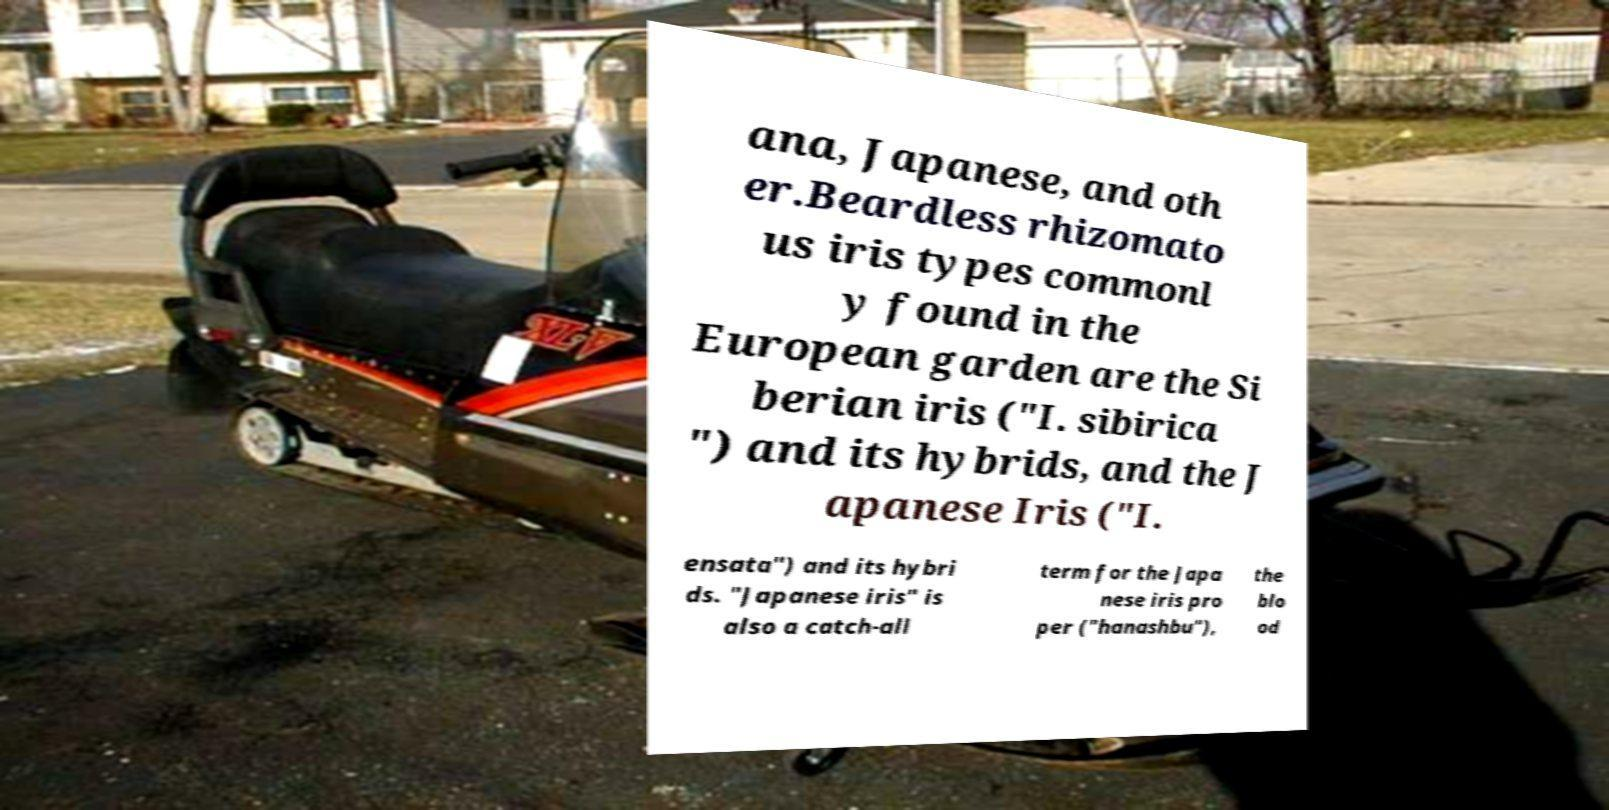Can you accurately transcribe the text from the provided image for me? ana, Japanese, and oth er.Beardless rhizomato us iris types commonl y found in the European garden are the Si berian iris ("I. sibirica ") and its hybrids, and the J apanese Iris ("I. ensata") and its hybri ds. "Japanese iris" is also a catch-all term for the Japa nese iris pro per ("hanashbu"), the blo od 